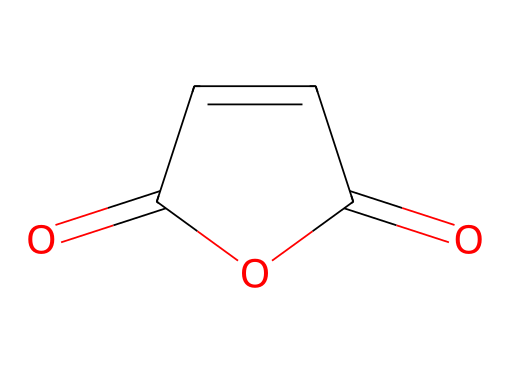What is the total number of carbon atoms in maleic anhydride? In the structural representation of maleic anhydride, there are two carbon atoms present in the ring structure and one outside due to the anhydride formation. Therefore, the total number is three.
Answer: three How many oxygen atoms are present in maleic anhydride? The structure shows a total of three oxygen atoms: two that are part of the carbonyl groups and one that is part of the anhydride moiety.
Answer: three What type of functional group does maleic anhydride contain? The maleic anhydride structure includes an anhydride functional group, which is characterized by the presence of the cyclic formula featuring multiple carbonyl groups (C=O).
Answer: anhydride What is the bond type between the carbon and oxygen atoms in maleic anhydride? The bonds between the carbon and oxygen in the structure are double bonds, specifically the carbonyl bonds (C=O) found in the anhydride functional group.
Answer: double bond What is the primary reason for using maleic anhydride in coatings for IoT devices? The primary reason for using maleic anhydride in corrosion-resistant coatings is its reactivity and ability to form strong cross-links, enhancing the durability and protective performance of the coating.
Answer: reactivity Can maleic anhydride act as a monomer in polymerization? Yes, maleic anhydride can act as a monomer in polymerization reactions, contributing to the formation of various copolymers due to its reactive anhydride functionality.
Answer: yes 